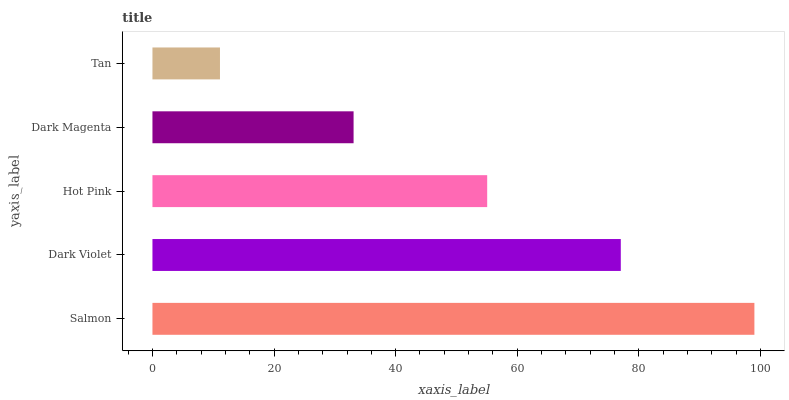Is Tan the minimum?
Answer yes or no. Yes. Is Salmon the maximum?
Answer yes or no. Yes. Is Dark Violet the minimum?
Answer yes or no. No. Is Dark Violet the maximum?
Answer yes or no. No. Is Salmon greater than Dark Violet?
Answer yes or no. Yes. Is Dark Violet less than Salmon?
Answer yes or no. Yes. Is Dark Violet greater than Salmon?
Answer yes or no. No. Is Salmon less than Dark Violet?
Answer yes or no. No. Is Hot Pink the high median?
Answer yes or no. Yes. Is Hot Pink the low median?
Answer yes or no. Yes. Is Dark Violet the high median?
Answer yes or no. No. Is Dark Magenta the low median?
Answer yes or no. No. 